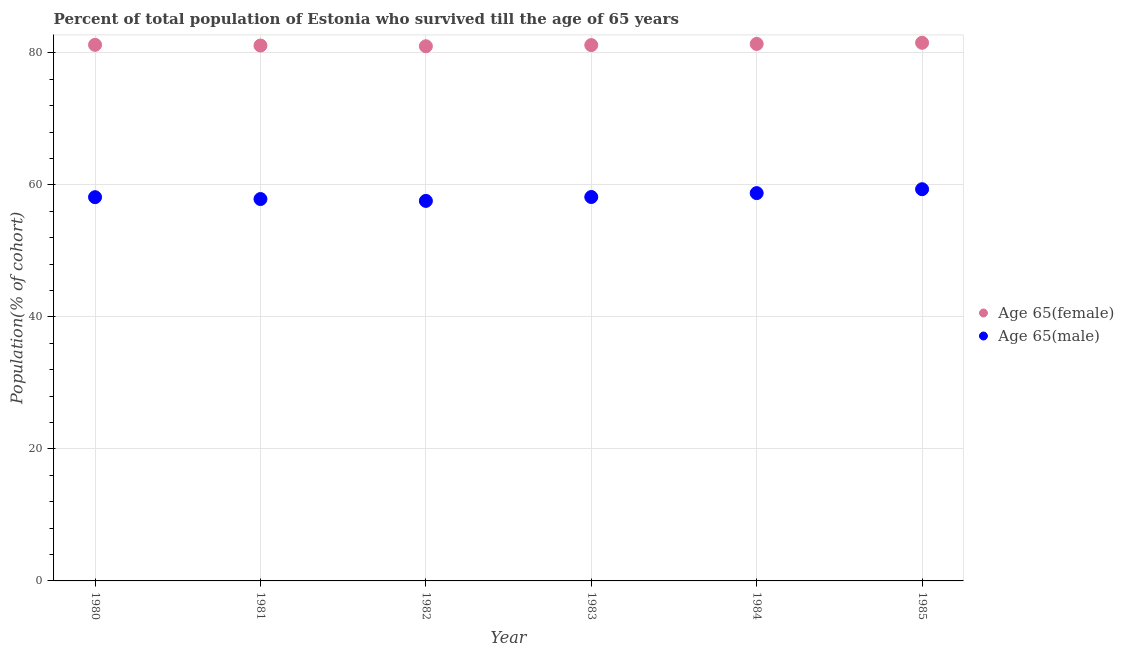What is the percentage of male population who survived till age of 65 in 1983?
Give a very brief answer. 58.17. Across all years, what is the maximum percentage of female population who survived till age of 65?
Your answer should be compact. 81.54. Across all years, what is the minimum percentage of female population who survived till age of 65?
Your response must be concise. 81.01. In which year was the percentage of male population who survived till age of 65 maximum?
Your answer should be very brief. 1985. In which year was the percentage of female population who survived till age of 65 minimum?
Provide a short and direct response. 1982. What is the total percentage of female population who survived till age of 65 in the graph?
Your answer should be compact. 487.45. What is the difference between the percentage of female population who survived till age of 65 in 1981 and that in 1983?
Your answer should be very brief. -0.07. What is the difference between the percentage of male population who survived till age of 65 in 1985 and the percentage of female population who survived till age of 65 in 1983?
Offer a very short reply. -21.84. What is the average percentage of male population who survived till age of 65 per year?
Provide a short and direct response. 58.31. In the year 1982, what is the difference between the percentage of female population who survived till age of 65 and percentage of male population who survived till age of 65?
Your answer should be very brief. 23.43. In how many years, is the percentage of male population who survived till age of 65 greater than 44 %?
Provide a succinct answer. 6. What is the ratio of the percentage of male population who survived till age of 65 in 1982 to that in 1984?
Provide a succinct answer. 0.98. Is the difference between the percentage of male population who survived till age of 65 in 1982 and 1985 greater than the difference between the percentage of female population who survived till age of 65 in 1982 and 1985?
Ensure brevity in your answer.  No. What is the difference between the highest and the second highest percentage of male population who survived till age of 65?
Your answer should be very brief. 0.59. What is the difference between the highest and the lowest percentage of male population who survived till age of 65?
Your answer should be compact. 1.77. In how many years, is the percentage of female population who survived till age of 65 greater than the average percentage of female population who survived till age of 65 taken over all years?
Your answer should be compact. 2. Is the sum of the percentage of male population who survived till age of 65 in 1981 and 1984 greater than the maximum percentage of female population who survived till age of 65 across all years?
Keep it short and to the point. Yes. Does the percentage of female population who survived till age of 65 monotonically increase over the years?
Provide a succinct answer. No. Is the percentage of male population who survived till age of 65 strictly less than the percentage of female population who survived till age of 65 over the years?
Offer a very short reply. Yes. What is the difference between two consecutive major ticks on the Y-axis?
Ensure brevity in your answer.  20. Does the graph contain any zero values?
Provide a short and direct response. No. Does the graph contain grids?
Give a very brief answer. Yes. Where does the legend appear in the graph?
Offer a very short reply. Center right. How many legend labels are there?
Your response must be concise. 2. How are the legend labels stacked?
Make the answer very short. Vertical. What is the title of the graph?
Keep it short and to the point. Percent of total population of Estonia who survived till the age of 65 years. Does "2012 US$" appear as one of the legend labels in the graph?
Offer a very short reply. No. What is the label or title of the Y-axis?
Offer a terse response. Population(% of cohort). What is the Population(% of cohort) in Age 65(female) in 1980?
Provide a short and direct response. 81.23. What is the Population(% of cohort) of Age 65(male) in 1980?
Keep it short and to the point. 58.14. What is the Population(% of cohort) of Age 65(female) in 1981?
Your answer should be very brief. 81.12. What is the Population(% of cohort) of Age 65(male) in 1981?
Provide a short and direct response. 57.86. What is the Population(% of cohort) in Age 65(female) in 1982?
Provide a short and direct response. 81.01. What is the Population(% of cohort) of Age 65(male) in 1982?
Offer a very short reply. 57.58. What is the Population(% of cohort) in Age 65(female) in 1983?
Make the answer very short. 81.19. What is the Population(% of cohort) in Age 65(male) in 1983?
Your answer should be compact. 58.17. What is the Population(% of cohort) of Age 65(female) in 1984?
Your answer should be very brief. 81.36. What is the Population(% of cohort) in Age 65(male) in 1984?
Give a very brief answer. 58.76. What is the Population(% of cohort) of Age 65(female) in 1985?
Offer a terse response. 81.54. What is the Population(% of cohort) in Age 65(male) in 1985?
Offer a very short reply. 59.35. Across all years, what is the maximum Population(% of cohort) in Age 65(female)?
Make the answer very short. 81.54. Across all years, what is the maximum Population(% of cohort) in Age 65(male)?
Provide a succinct answer. 59.35. Across all years, what is the minimum Population(% of cohort) of Age 65(female)?
Offer a very short reply. 81.01. Across all years, what is the minimum Population(% of cohort) in Age 65(male)?
Make the answer very short. 57.58. What is the total Population(% of cohort) of Age 65(female) in the graph?
Your answer should be compact. 487.45. What is the total Population(% of cohort) of Age 65(male) in the graph?
Make the answer very short. 349.87. What is the difference between the Population(% of cohort) of Age 65(female) in 1980 and that in 1981?
Give a very brief answer. 0.11. What is the difference between the Population(% of cohort) in Age 65(male) in 1980 and that in 1981?
Offer a very short reply. 0.28. What is the difference between the Population(% of cohort) of Age 65(female) in 1980 and that in 1982?
Offer a terse response. 0.21. What is the difference between the Population(% of cohort) of Age 65(male) in 1980 and that in 1982?
Provide a succinct answer. 0.56. What is the difference between the Population(% of cohort) of Age 65(female) in 1980 and that in 1983?
Keep it short and to the point. 0.04. What is the difference between the Population(% of cohort) of Age 65(male) in 1980 and that in 1983?
Provide a short and direct response. -0.03. What is the difference between the Population(% of cohort) of Age 65(female) in 1980 and that in 1984?
Your response must be concise. -0.14. What is the difference between the Population(% of cohort) of Age 65(male) in 1980 and that in 1984?
Ensure brevity in your answer.  -0.62. What is the difference between the Population(% of cohort) of Age 65(female) in 1980 and that in 1985?
Your response must be concise. -0.31. What is the difference between the Population(% of cohort) in Age 65(male) in 1980 and that in 1985?
Offer a terse response. -1.21. What is the difference between the Population(% of cohort) of Age 65(female) in 1981 and that in 1982?
Ensure brevity in your answer.  0.11. What is the difference between the Population(% of cohort) of Age 65(male) in 1981 and that in 1982?
Offer a very short reply. 0.28. What is the difference between the Population(% of cohort) in Age 65(female) in 1981 and that in 1983?
Provide a short and direct response. -0.07. What is the difference between the Population(% of cohort) in Age 65(male) in 1981 and that in 1983?
Provide a short and direct response. -0.31. What is the difference between the Population(% of cohort) in Age 65(female) in 1981 and that in 1984?
Provide a short and direct response. -0.24. What is the difference between the Population(% of cohort) in Age 65(male) in 1981 and that in 1984?
Offer a very short reply. -0.9. What is the difference between the Population(% of cohort) in Age 65(female) in 1981 and that in 1985?
Provide a short and direct response. -0.42. What is the difference between the Population(% of cohort) of Age 65(male) in 1981 and that in 1985?
Your answer should be compact. -1.49. What is the difference between the Population(% of cohort) of Age 65(female) in 1982 and that in 1983?
Provide a succinct answer. -0.18. What is the difference between the Population(% of cohort) of Age 65(male) in 1982 and that in 1983?
Offer a very short reply. -0.59. What is the difference between the Population(% of cohort) of Age 65(female) in 1982 and that in 1984?
Provide a short and direct response. -0.35. What is the difference between the Population(% of cohort) in Age 65(male) in 1982 and that in 1984?
Your response must be concise. -1.18. What is the difference between the Population(% of cohort) of Age 65(female) in 1982 and that in 1985?
Your response must be concise. -0.53. What is the difference between the Population(% of cohort) of Age 65(male) in 1982 and that in 1985?
Your answer should be compact. -1.77. What is the difference between the Population(% of cohort) in Age 65(female) in 1983 and that in 1984?
Provide a succinct answer. -0.18. What is the difference between the Population(% of cohort) in Age 65(male) in 1983 and that in 1984?
Your answer should be very brief. -0.59. What is the difference between the Population(% of cohort) of Age 65(female) in 1983 and that in 1985?
Ensure brevity in your answer.  -0.35. What is the difference between the Population(% of cohort) of Age 65(male) in 1983 and that in 1985?
Offer a terse response. -1.18. What is the difference between the Population(% of cohort) in Age 65(female) in 1984 and that in 1985?
Provide a short and direct response. -0.18. What is the difference between the Population(% of cohort) in Age 65(male) in 1984 and that in 1985?
Offer a very short reply. -0.59. What is the difference between the Population(% of cohort) in Age 65(female) in 1980 and the Population(% of cohort) in Age 65(male) in 1981?
Ensure brevity in your answer.  23.36. What is the difference between the Population(% of cohort) in Age 65(female) in 1980 and the Population(% of cohort) in Age 65(male) in 1982?
Your answer should be compact. 23.65. What is the difference between the Population(% of cohort) in Age 65(female) in 1980 and the Population(% of cohort) in Age 65(male) in 1983?
Your answer should be very brief. 23.05. What is the difference between the Population(% of cohort) in Age 65(female) in 1980 and the Population(% of cohort) in Age 65(male) in 1984?
Provide a short and direct response. 22.46. What is the difference between the Population(% of cohort) of Age 65(female) in 1980 and the Population(% of cohort) of Age 65(male) in 1985?
Keep it short and to the point. 21.87. What is the difference between the Population(% of cohort) in Age 65(female) in 1981 and the Population(% of cohort) in Age 65(male) in 1982?
Keep it short and to the point. 23.54. What is the difference between the Population(% of cohort) in Age 65(female) in 1981 and the Population(% of cohort) in Age 65(male) in 1983?
Your answer should be compact. 22.95. What is the difference between the Population(% of cohort) in Age 65(female) in 1981 and the Population(% of cohort) in Age 65(male) in 1984?
Ensure brevity in your answer.  22.36. What is the difference between the Population(% of cohort) in Age 65(female) in 1981 and the Population(% of cohort) in Age 65(male) in 1985?
Give a very brief answer. 21.77. What is the difference between the Population(% of cohort) of Age 65(female) in 1982 and the Population(% of cohort) of Age 65(male) in 1983?
Give a very brief answer. 22.84. What is the difference between the Population(% of cohort) in Age 65(female) in 1982 and the Population(% of cohort) in Age 65(male) in 1984?
Provide a short and direct response. 22.25. What is the difference between the Population(% of cohort) of Age 65(female) in 1982 and the Population(% of cohort) of Age 65(male) in 1985?
Offer a very short reply. 21.66. What is the difference between the Population(% of cohort) of Age 65(female) in 1983 and the Population(% of cohort) of Age 65(male) in 1984?
Give a very brief answer. 22.43. What is the difference between the Population(% of cohort) in Age 65(female) in 1983 and the Population(% of cohort) in Age 65(male) in 1985?
Offer a terse response. 21.84. What is the difference between the Population(% of cohort) in Age 65(female) in 1984 and the Population(% of cohort) in Age 65(male) in 1985?
Ensure brevity in your answer.  22.01. What is the average Population(% of cohort) of Age 65(female) per year?
Your response must be concise. 81.24. What is the average Population(% of cohort) in Age 65(male) per year?
Give a very brief answer. 58.31. In the year 1980, what is the difference between the Population(% of cohort) in Age 65(female) and Population(% of cohort) in Age 65(male)?
Make the answer very short. 23.08. In the year 1981, what is the difference between the Population(% of cohort) in Age 65(female) and Population(% of cohort) in Age 65(male)?
Keep it short and to the point. 23.26. In the year 1982, what is the difference between the Population(% of cohort) of Age 65(female) and Population(% of cohort) of Age 65(male)?
Keep it short and to the point. 23.43. In the year 1983, what is the difference between the Population(% of cohort) in Age 65(female) and Population(% of cohort) in Age 65(male)?
Offer a terse response. 23.02. In the year 1984, what is the difference between the Population(% of cohort) of Age 65(female) and Population(% of cohort) of Age 65(male)?
Give a very brief answer. 22.6. In the year 1985, what is the difference between the Population(% of cohort) in Age 65(female) and Population(% of cohort) in Age 65(male)?
Offer a terse response. 22.19. What is the ratio of the Population(% of cohort) of Age 65(female) in 1980 to that in 1981?
Your response must be concise. 1. What is the ratio of the Population(% of cohort) of Age 65(male) in 1980 to that in 1982?
Your answer should be very brief. 1.01. What is the ratio of the Population(% of cohort) in Age 65(female) in 1980 to that in 1983?
Your answer should be compact. 1. What is the ratio of the Population(% of cohort) in Age 65(male) in 1980 to that in 1983?
Keep it short and to the point. 1. What is the ratio of the Population(% of cohort) in Age 65(male) in 1980 to that in 1984?
Your answer should be compact. 0.99. What is the ratio of the Population(% of cohort) of Age 65(female) in 1980 to that in 1985?
Your answer should be very brief. 1. What is the ratio of the Population(% of cohort) of Age 65(male) in 1980 to that in 1985?
Make the answer very short. 0.98. What is the ratio of the Population(% of cohort) in Age 65(female) in 1981 to that in 1982?
Your response must be concise. 1. What is the ratio of the Population(% of cohort) in Age 65(male) in 1981 to that in 1982?
Provide a short and direct response. 1. What is the ratio of the Population(% of cohort) in Age 65(female) in 1981 to that in 1983?
Your answer should be very brief. 1. What is the ratio of the Population(% of cohort) of Age 65(female) in 1981 to that in 1984?
Your answer should be compact. 1. What is the ratio of the Population(% of cohort) in Age 65(male) in 1981 to that in 1984?
Ensure brevity in your answer.  0.98. What is the ratio of the Population(% of cohort) of Age 65(male) in 1981 to that in 1985?
Provide a short and direct response. 0.97. What is the ratio of the Population(% of cohort) of Age 65(male) in 1982 to that in 1983?
Provide a short and direct response. 0.99. What is the ratio of the Population(% of cohort) in Age 65(male) in 1982 to that in 1984?
Offer a very short reply. 0.98. What is the ratio of the Population(% of cohort) in Age 65(male) in 1982 to that in 1985?
Offer a very short reply. 0.97. What is the ratio of the Population(% of cohort) in Age 65(female) in 1983 to that in 1984?
Keep it short and to the point. 1. What is the ratio of the Population(% of cohort) in Age 65(male) in 1983 to that in 1985?
Make the answer very short. 0.98. What is the ratio of the Population(% of cohort) of Age 65(female) in 1984 to that in 1985?
Your answer should be compact. 1. What is the difference between the highest and the second highest Population(% of cohort) in Age 65(female)?
Offer a terse response. 0.18. What is the difference between the highest and the second highest Population(% of cohort) of Age 65(male)?
Provide a succinct answer. 0.59. What is the difference between the highest and the lowest Population(% of cohort) of Age 65(female)?
Provide a short and direct response. 0.53. What is the difference between the highest and the lowest Population(% of cohort) of Age 65(male)?
Keep it short and to the point. 1.77. 